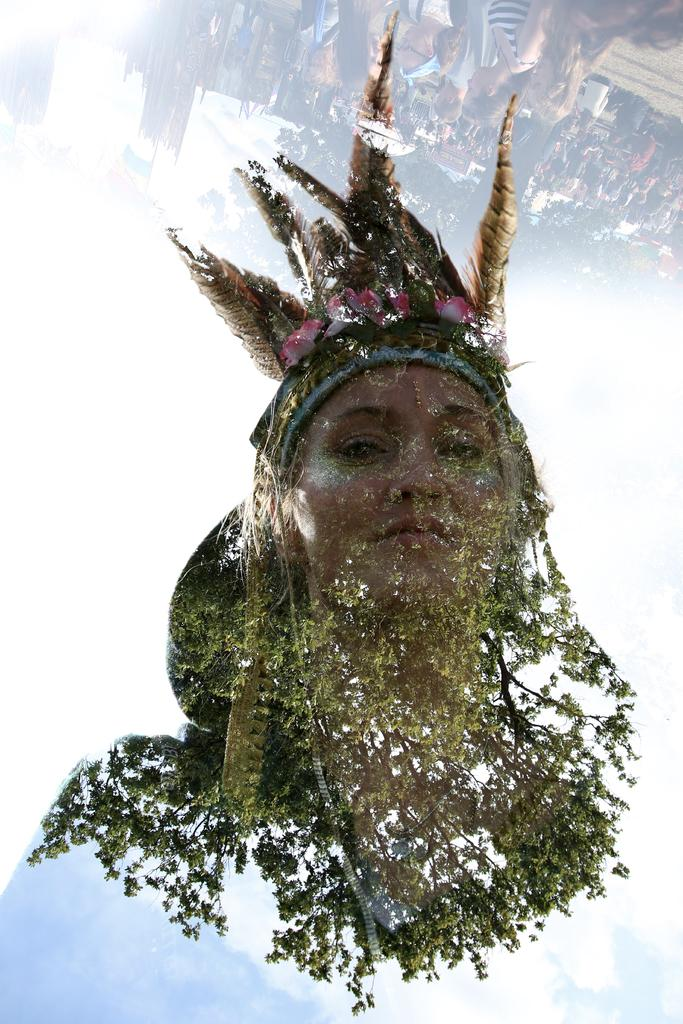What is the main subject of the image? There is a person's face in the image. What can be seen in the background of the image? There are trees and buildings in the image. Are there any other people visible in the image? Yes, there are persons standing in the image. What is visible in the sky in the image? The sky is visible in the image. Can you describe the fight between the spade and the lake in the image? There is no fight between a spade and a lake in the image, as neither a spade nor a lake is present. 